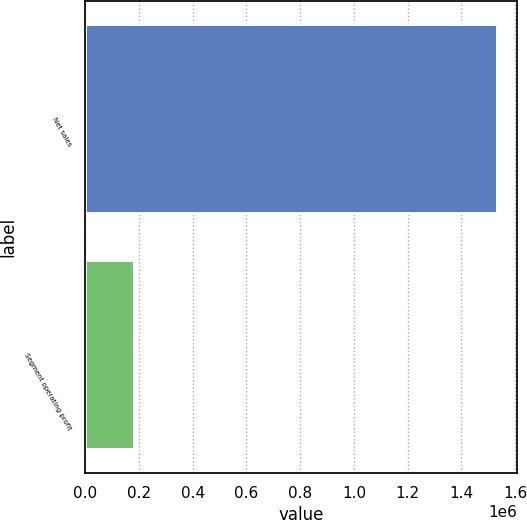Convert chart to OTSL. <chart><loc_0><loc_0><loc_500><loc_500><bar_chart><fcel>Net sales<fcel>Segment operating profit<nl><fcel>1.53191e+06<fcel>179917<nl></chart> 